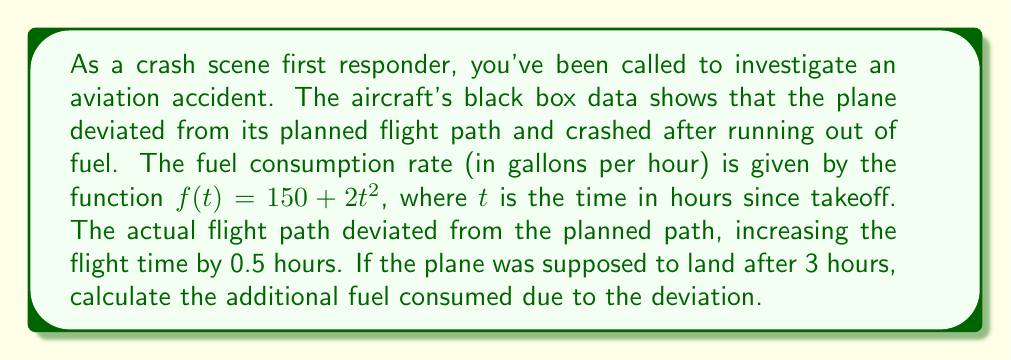Can you answer this question? To solve this problem, we need to use definite integrals to calculate the total fuel consumption for both the planned flight and the actual flight, then find the difference.

1) For the planned flight (3 hours):
   $$\int_0^3 (150 + 2t^2) dt$$

2) For the actual flight (3.5 hours):
   $$\int_0^{3.5} (150 + 2t^2) dt$$

3) Let's solve the integral:
   $$\int (150 + 2t^2) dt = 150t + \frac{2t^3}{3} + C$$

4) For the planned flight:
   $$[150t + \frac{2t^3}{3}]_0^3 = (450 + 18) - (0 + 0) = 468$$

5) For the actual flight:
   $$[150t + \frac{2t^3}{3}]_0^{3.5} = (525 + 28.58) - (0 + 0) = 553.58$$

6) The difference in fuel consumption:
   $$553.58 - 468 = 85.58$$

Therefore, the additional fuel consumed due to the deviation is approximately 85.58 gallons.
Answer: 85.58 gallons 